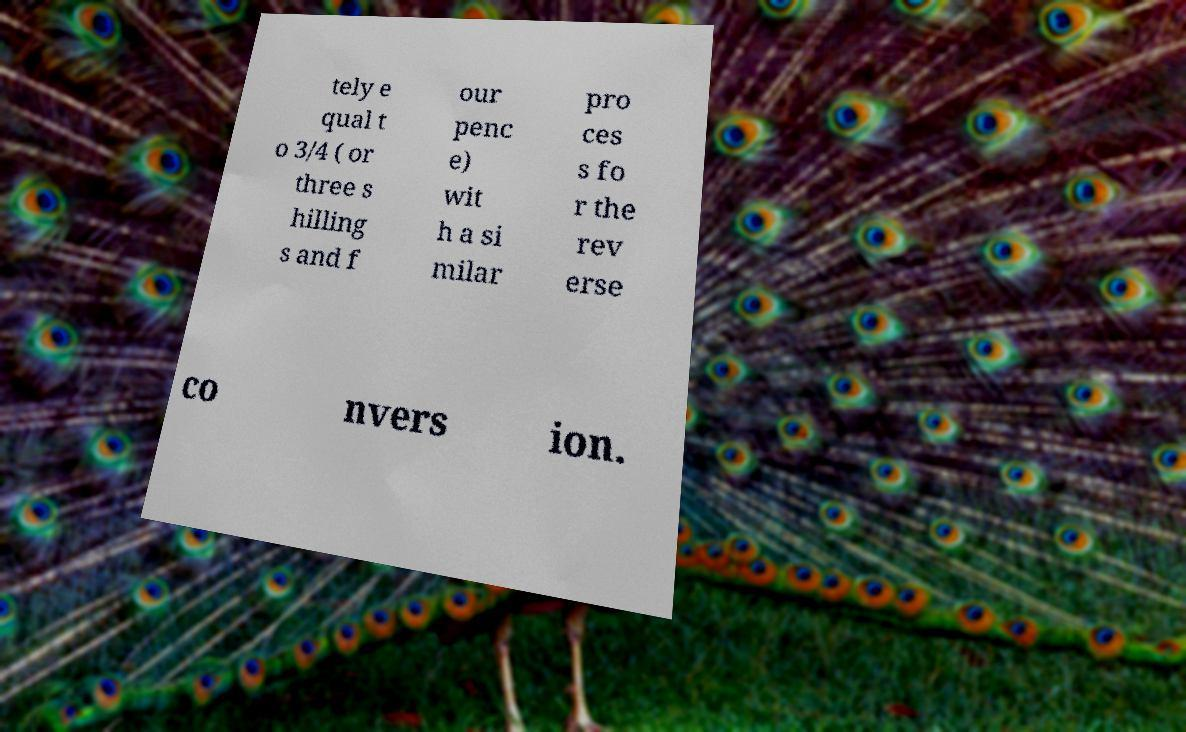Could you extract and type out the text from this image? tely e qual t o 3/4 ( or three s hilling s and f our penc e) wit h a si milar pro ces s fo r the rev erse co nvers ion. 